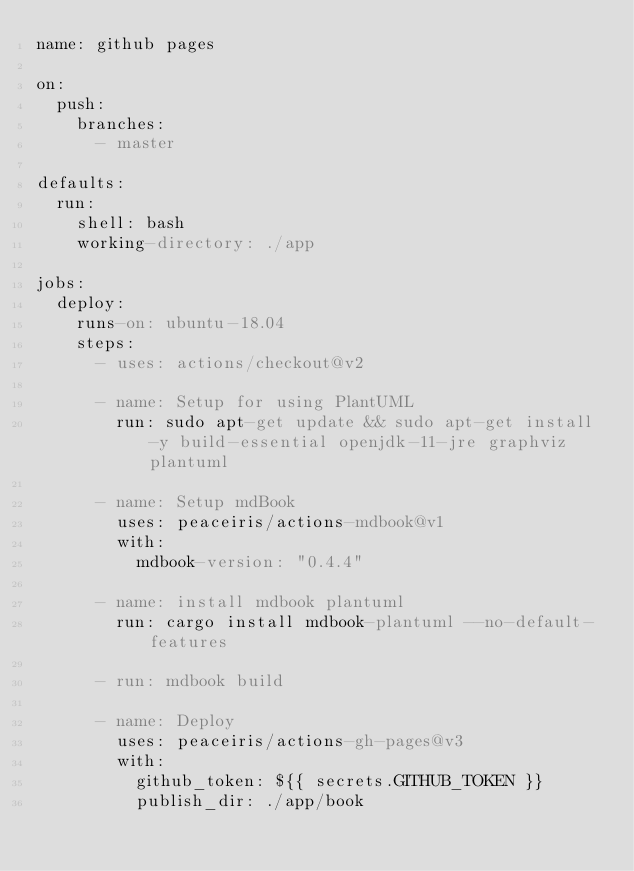<code> <loc_0><loc_0><loc_500><loc_500><_YAML_>name: github pages

on:
  push:
    branches:
      - master

defaults:
  run:
    shell: bash
    working-directory: ./app

jobs:
  deploy:
    runs-on: ubuntu-18.04
    steps:
      - uses: actions/checkout@v2

      - name: Setup for using PlantUML
        run: sudo apt-get update && sudo apt-get install -y build-essential openjdk-11-jre graphviz plantuml

      - name: Setup mdBook
        uses: peaceiris/actions-mdbook@v1
        with:
          mdbook-version: "0.4.4"

      - name: install mdbook plantuml
        run: cargo install mdbook-plantuml --no-default-features

      - run: mdbook build

      - name: Deploy
        uses: peaceiris/actions-gh-pages@v3
        with:
          github_token: ${{ secrets.GITHUB_TOKEN }}
          publish_dir: ./app/book
</code> 